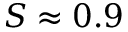Convert formula to latex. <formula><loc_0><loc_0><loc_500><loc_500>S \approx 0 . 9</formula> 